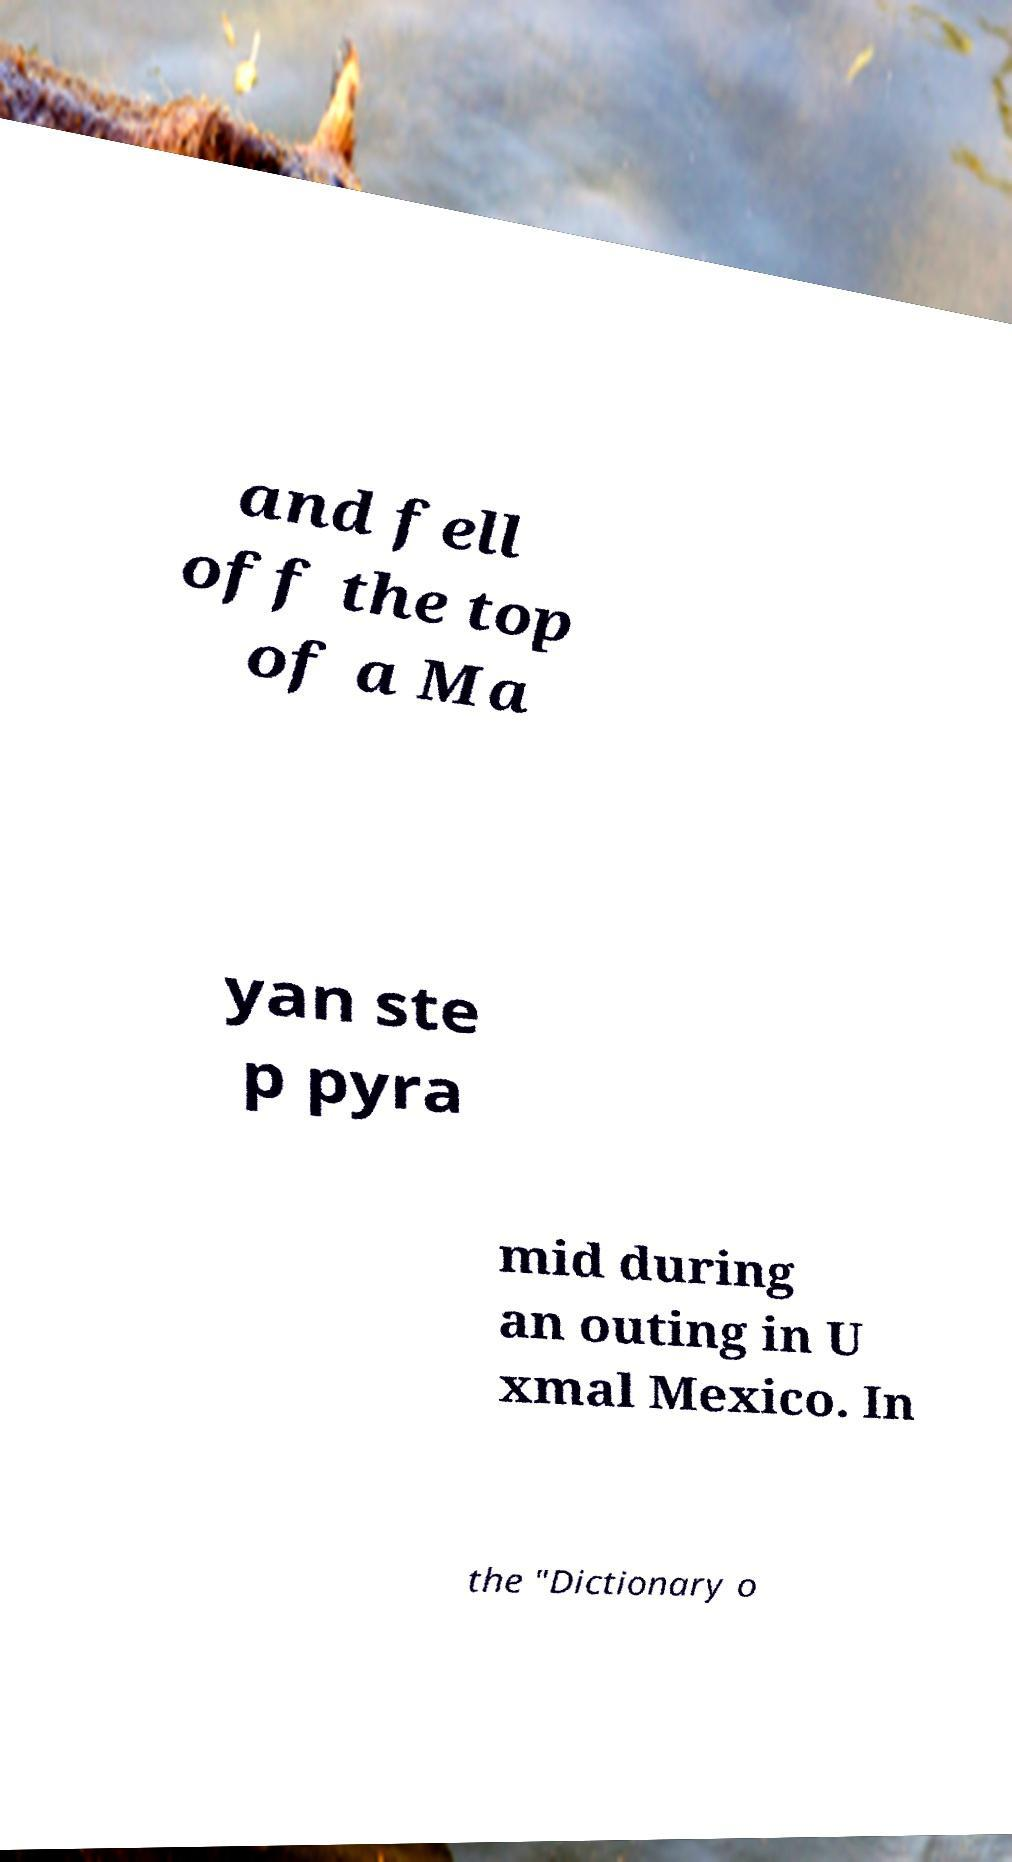I need the written content from this picture converted into text. Can you do that? and fell off the top of a Ma yan ste p pyra mid during an outing in U xmal Mexico. In the "Dictionary o 